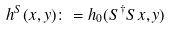Convert formula to latex. <formula><loc_0><loc_0><loc_500><loc_500>h ^ { S } ( x , y ) \colon = h _ { 0 } ( S ^ { \dagger } S x , y )</formula> 